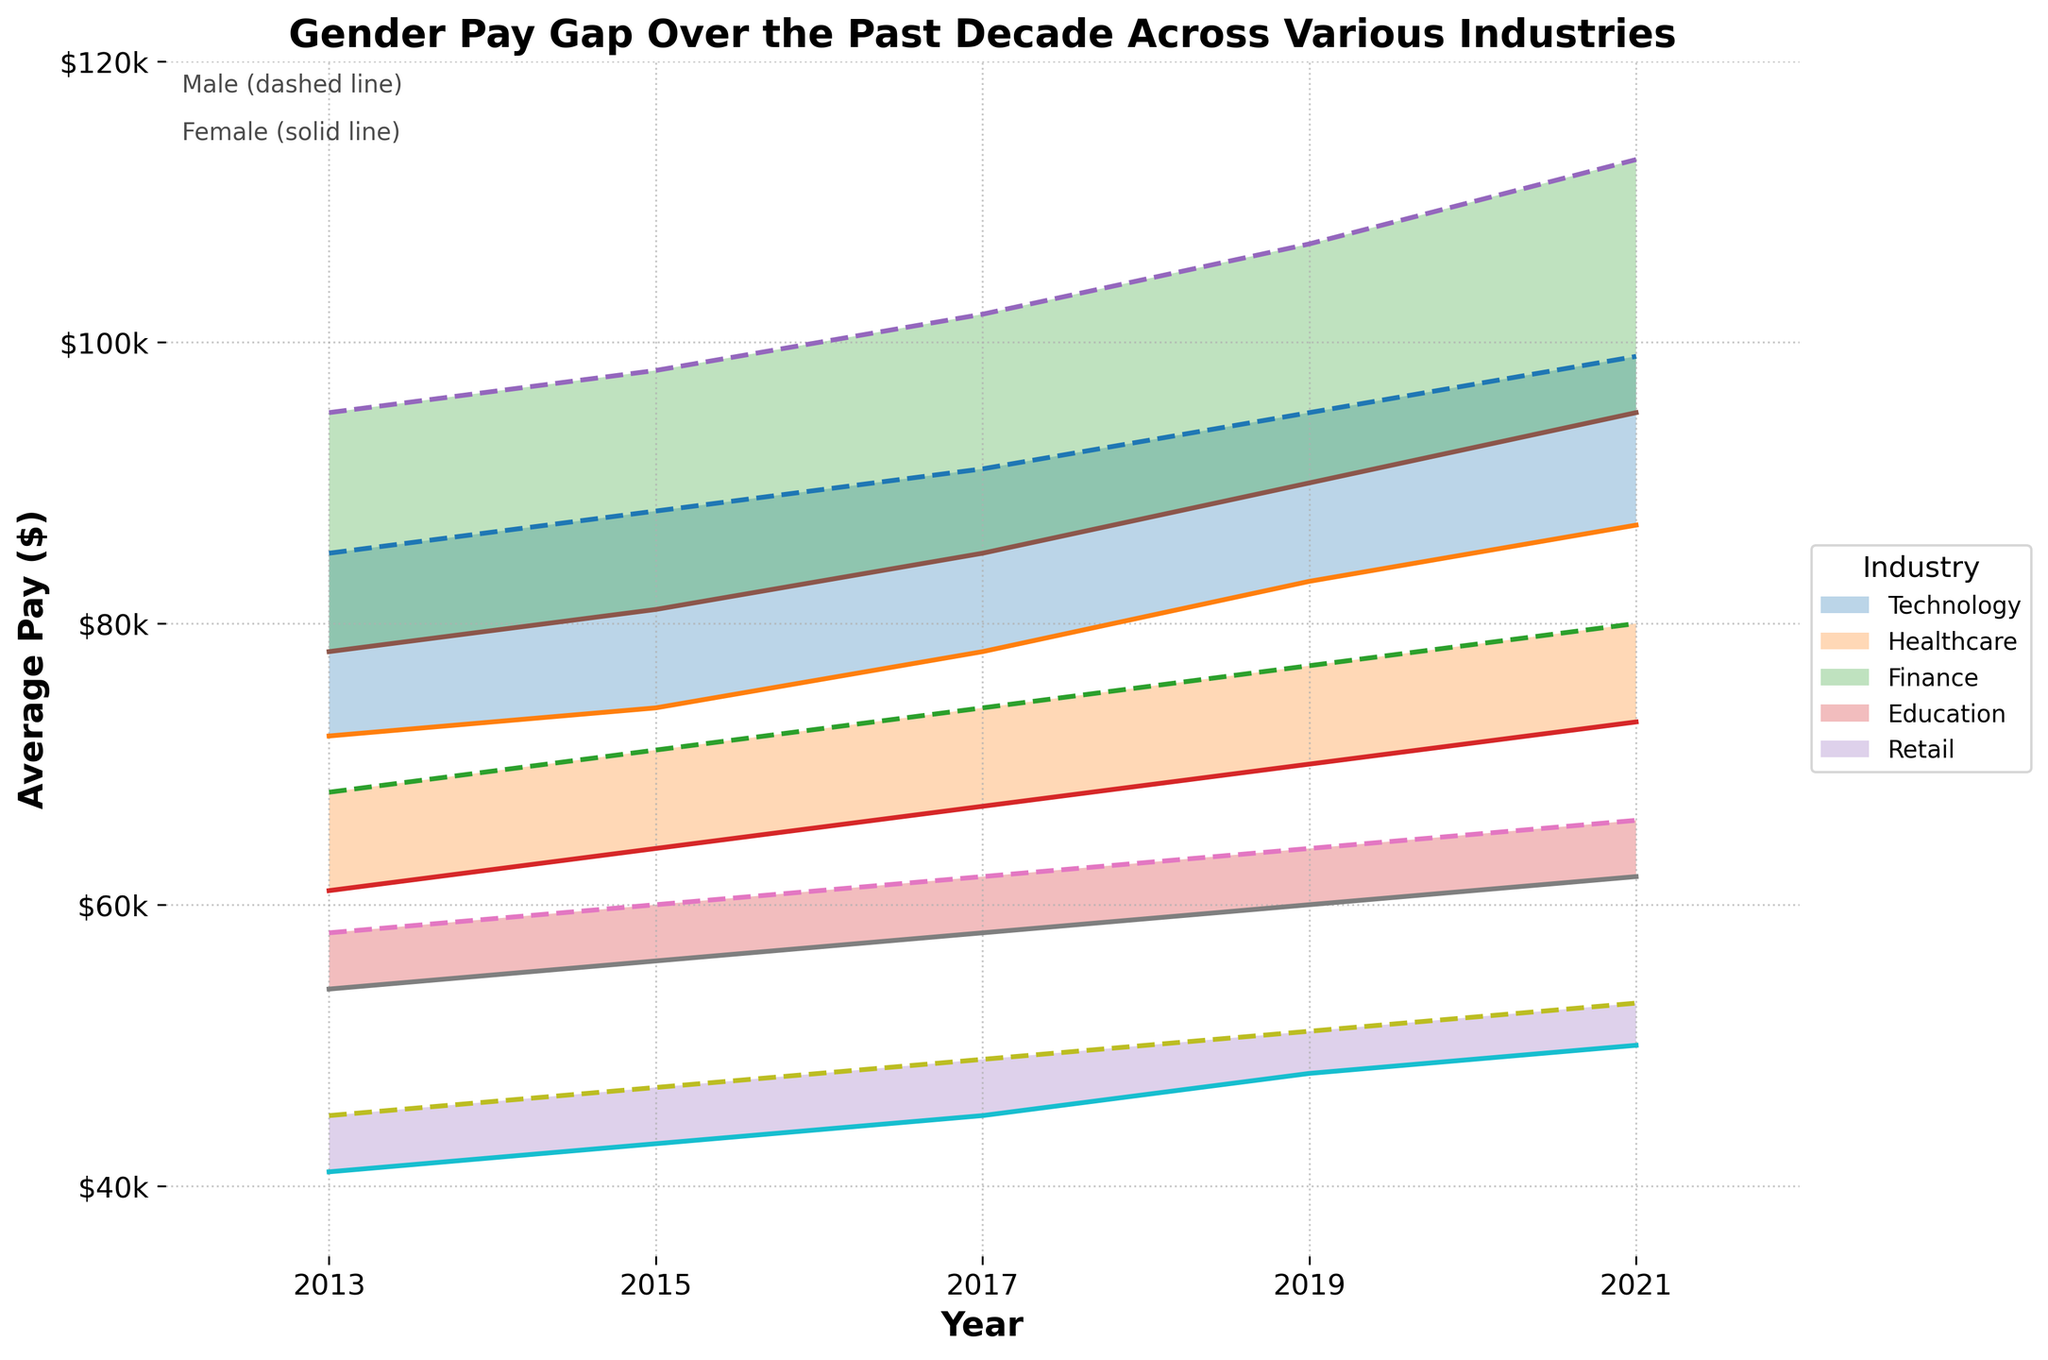What is the title of the figure? The title of the figure is written at the top of the plot and describes what the figure is about.
Answer: "Gender Pay Gap Over the Past Decade Across Various Industries" How many different industries are represented in the figure? By counting the unique labels in the legend, we can determine the number of industries. Each label corresponds to one industry.
Answer: Five Which industry has the highest average male pay in 2021? Look at the plot lines for each industry in 2021 and identify the industry with the highest male pay. Check the position of the dashed line for each industry in 2021.
Answer: Finance What is the pay gap between males and females in the Education industry in 2019? Find the values for male and female pay in the Education industry in 2019, and then calculate the difference. The male pay is 64,000 and female pay is 60,000. The pay gap is 64,000 - 60,000.
Answer: $4,000 From 2013 to 2021, which industry showed the smallest decrease in the gender pay gap? First, calculate the pay gap for each year from 2013 to 2021 for each industry. Then, compare the changes in the pay gaps over the years to find the industry with the smallest decrease.
Answer: Retail Which year had the largest pay gap in the Technology industry? Analyze the pay gap data for each year within the Technology industry. Find the year where the difference between male and female pay is the largest.
Answer: 2013 What trend can be observed about the pay average for females in the Healthcare industry from 2013 to 2021? Look at the solid line representing female pay in the Healthcare industry from 2013 to 2021. It's important to observe if it shows an increasing, decreasing, or constant trend.
Answer: Increasing In which industry did the female pay average reach $95,000 in 2021? Identify the solid line that intersects $95,000 in the y-axis in 2021. This line represents the female pay average.
Answer: Finance Comparing Technology and Education industries, which one has a larger gender pay gap in 2021? Calculate the difference between male and female pay for each industry in 2021 and compare the gaps. Technology: 99,000 - 87,000; Education: 66,000 - 62,000.
Answer: Technology How does the pay gap between males and females in the Finance industry change from 2013 to 2021? Determine the pay gaps for the years 2013, 2015, 2017, 2019, and 2021 by subtracting female pay from male pay for each year. Observe the changes over time.
Answer: Widens 